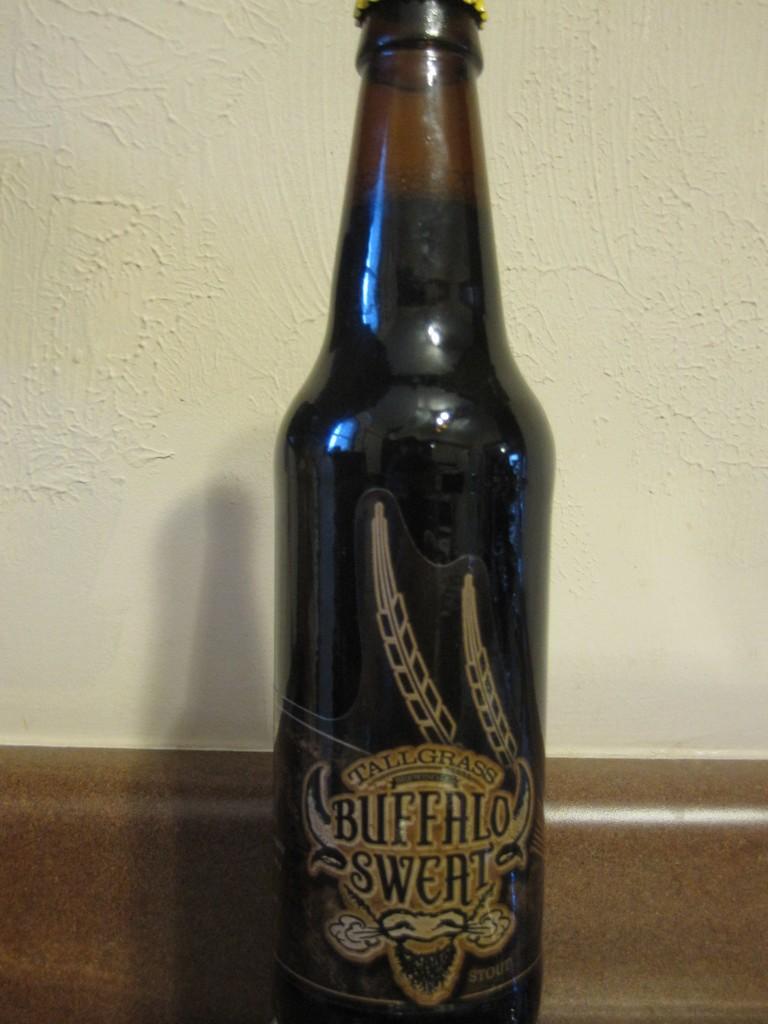What animal is the mascot of this beer?
Provide a short and direct response. Buffalo. What kind of grass is mentioned on the bottle?
Your response must be concise. Tall. 